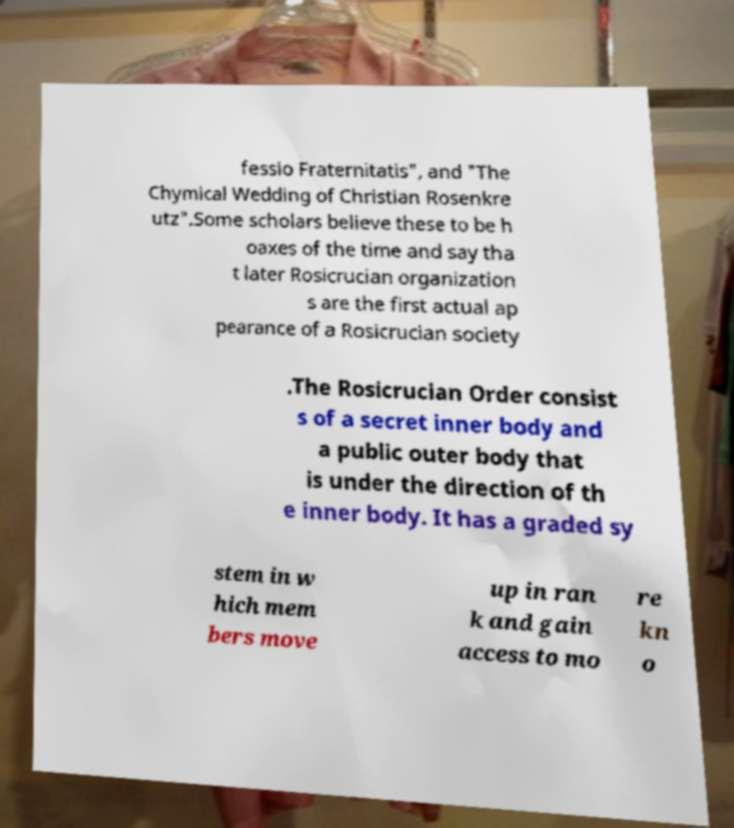Can you read and provide the text displayed in the image?This photo seems to have some interesting text. Can you extract and type it out for me? fessio Fraternitatis", and "The Chymical Wedding of Christian Rosenkre utz".Some scholars believe these to be h oaxes of the time and say tha t later Rosicrucian organization s are the first actual ap pearance of a Rosicrucian society .The Rosicrucian Order consist s of a secret inner body and a public outer body that is under the direction of th e inner body. It has a graded sy stem in w hich mem bers move up in ran k and gain access to mo re kn o 